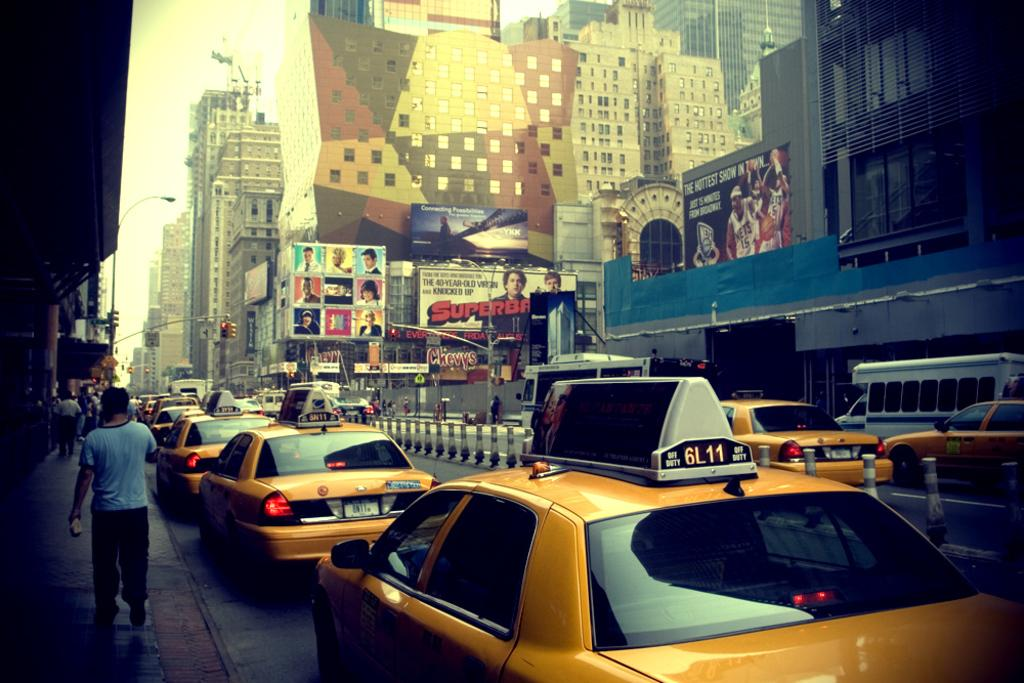<image>
Relay a brief, clear account of the picture shown. A Picture looks like a downtown with lines of Yellow cabs and people walking on the sidewalk. 